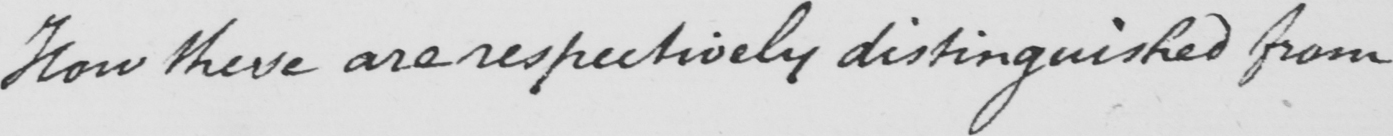Please provide the text content of this handwritten line. How these are respectively distinguished from 